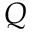<formula> <loc_0><loc_0><loc_500><loc_500>Q</formula> 